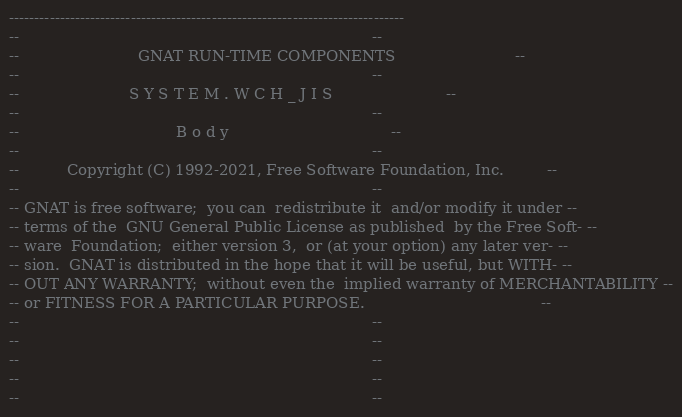Convert code to text. <code><loc_0><loc_0><loc_500><loc_500><_Ada_>------------------------------------------------------------------------------
--                                                                          --
--                         GNAT RUN-TIME COMPONENTS                         --
--                                                                          --
--                       S Y S T E M . W C H _ J I S                        --
--                                                                          --
--                                 B o d y                                  --
--                                                                          --
--          Copyright (C) 1992-2021, Free Software Foundation, Inc.         --
--                                                                          --
-- GNAT is free software;  you can  redistribute it  and/or modify it under --
-- terms of the  GNU General Public License as published  by the Free Soft- --
-- ware  Foundation;  either version 3,  or (at your option) any later ver- --
-- sion.  GNAT is distributed in the hope that it will be useful, but WITH- --
-- OUT ANY WARRANTY;  without even the  implied warranty of MERCHANTABILITY --
-- or FITNESS FOR A PARTICULAR PURPOSE.                                     --
--                                                                          --
--                                                                          --
--                                                                          --
--                                                                          --
--                                                                          --</code> 